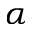<formula> <loc_0><loc_0><loc_500><loc_500>\alpha</formula> 